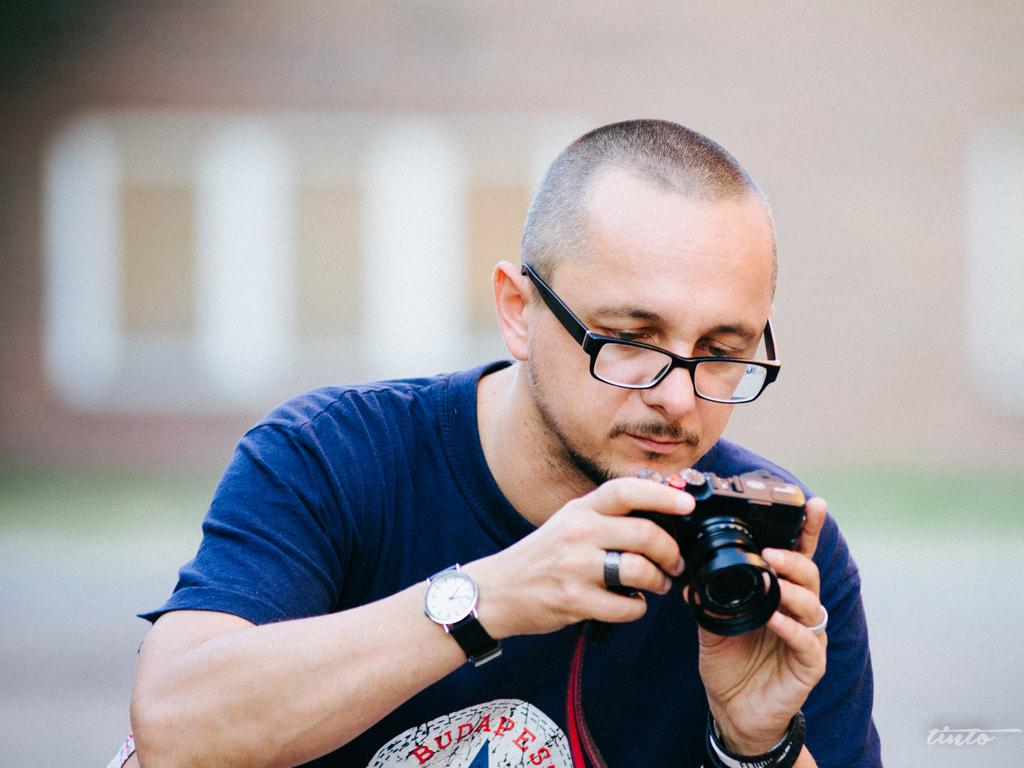Who is the main subject in the image? There is a man in the image. What is the man wearing? The man is wearing a t-shirt. What is the man holding in his hand? The man is holding a camera in his hand. What is the man doing with the camera? The man is checking something on the camera. What type of pen is the man using to draw on the cave wall in the image? There is no pen or cave wall present in the image; it features a man holding a camera. What flag is the man holding up in the image? There is no flag present in the image; it features a man holding a camera. 